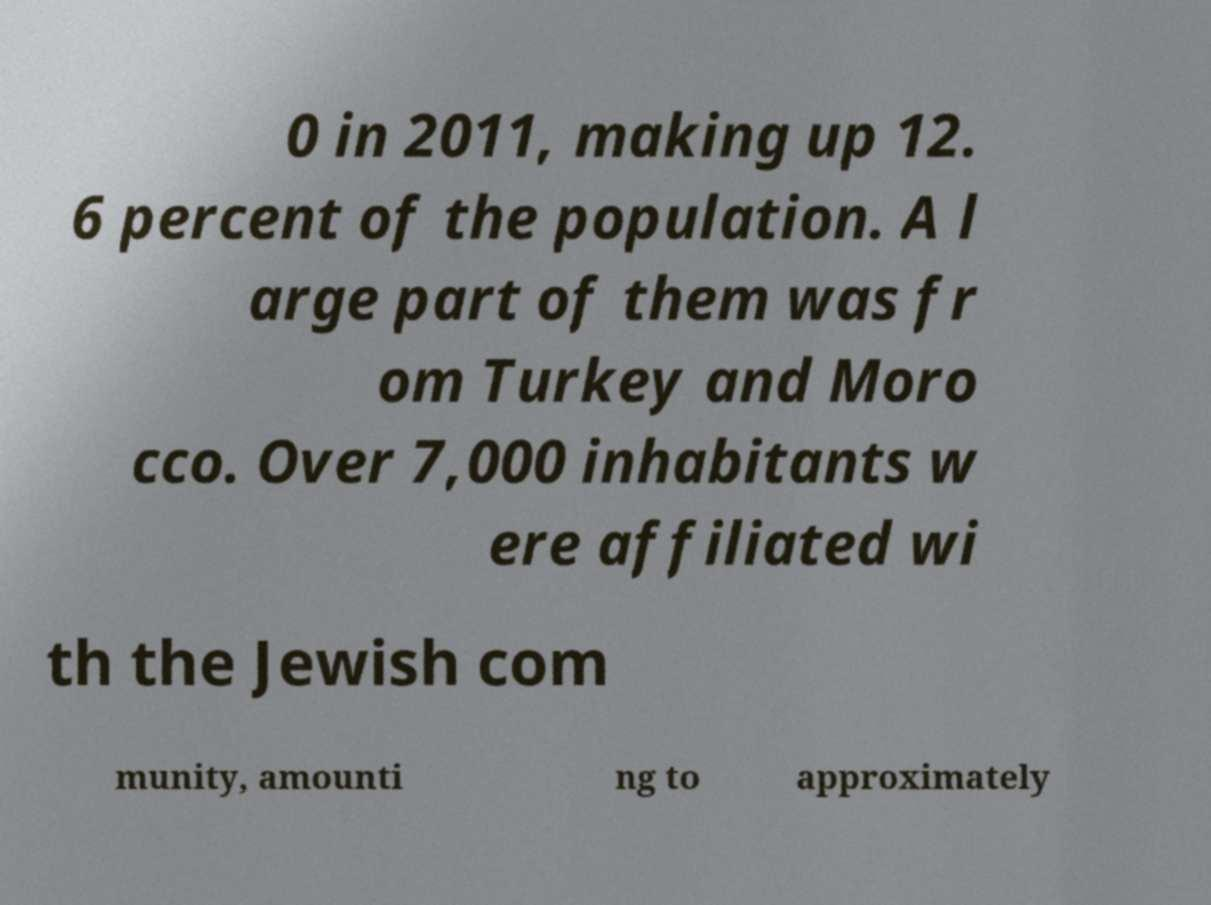What messages or text are displayed in this image? I need them in a readable, typed format. 0 in 2011, making up 12. 6 percent of the population. A l arge part of them was fr om Turkey and Moro cco. Over 7,000 inhabitants w ere affiliated wi th the Jewish com munity, amounti ng to approximately 